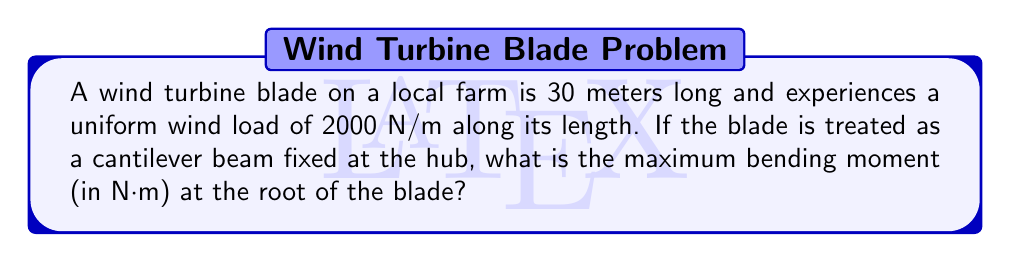Provide a solution to this math problem. Let's approach this step-by-step:

1) The blade can be modeled as a cantilever beam with a distributed load.

2) For a cantilever beam with a uniform distributed load, the maximum bending moment occurs at the fixed end (root of the blade).

3) The formula for maximum bending moment in this case is:

   $$M_{max} = \frac{wL^2}{2}$$

   Where:
   $M_{max}$ is the maximum bending moment
   $w$ is the uniform load per unit length
   $L$ is the length of the beam

4) We're given:
   $w = 2000$ N/m
   $L = 30$ m

5) Let's substitute these values into our equation:

   $$M_{max} = \frac{2000 \times 30^2}{2}$$

6) Simplify:
   $$M_{max} = \frac{2000 \times 900}{2} = 900,000$$ N⋅m

Therefore, the maximum bending moment at the root of the blade is 900,000 N⋅m.
Answer: 900,000 N⋅m 